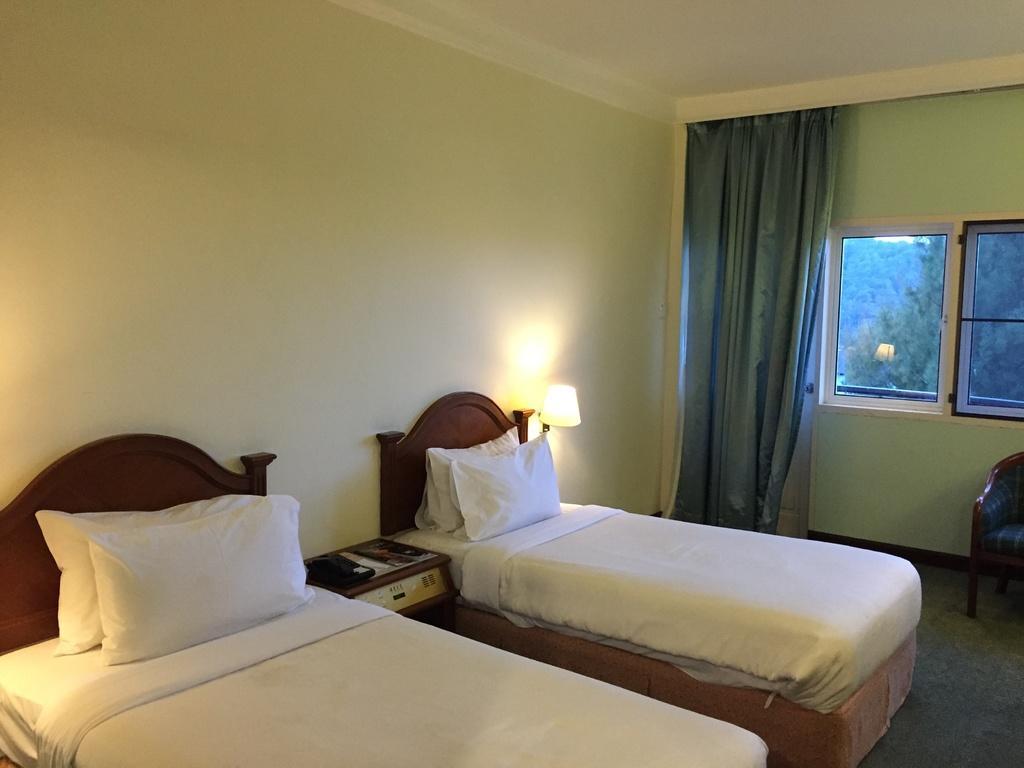Describe this image in one or two sentences. This pictures of inside the room. In the foreground we can see there are two beds and the top of which two pillows are placed and there is a side table, side lamp. In the background we can see there is a chair window, wall and a curtain. 